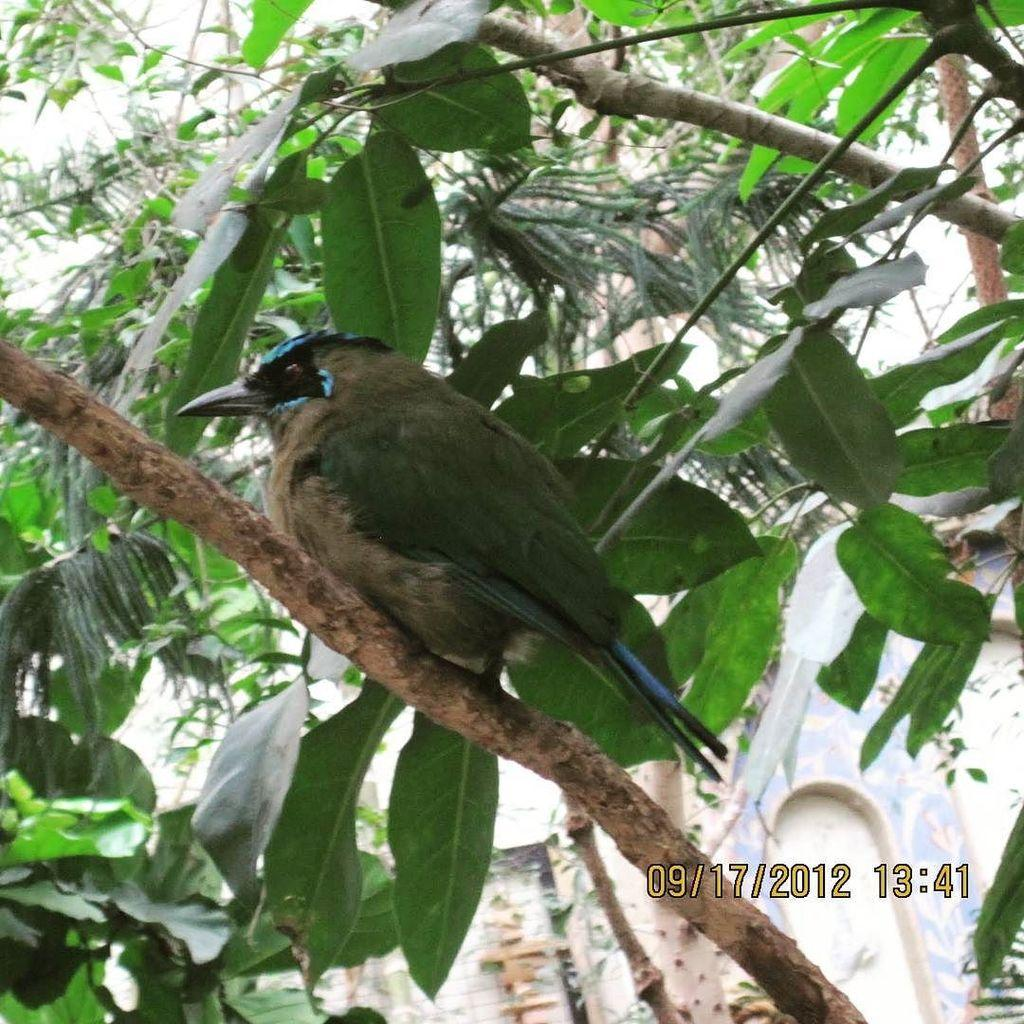What type of animal can be seen in the image? There is a bird in the image. Where is the bird located? The bird is on a branch. What other natural elements are present in the image? There are trees in the image. What can be seen in the background of the image? There is a wall in the background of the image. Where is the playground located in the image? There is no playground present in the image. Can you describe the bird's bathing habits in the image? There is no indication of the bird bathing in the image. 